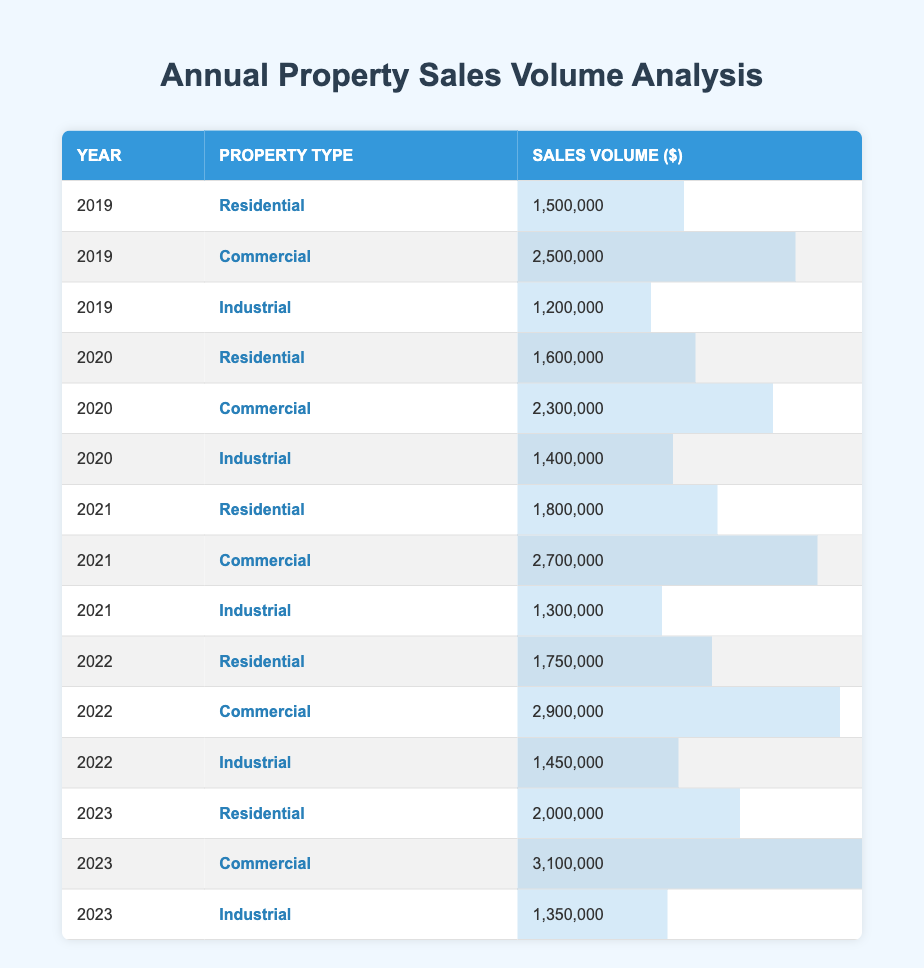What was the sales volume for Commercial properties in 2022? The table shows the row for 2022 under the Commercial property type, which states that the sales volume is 2,900,000.
Answer: 2,900,000 Which property type had the highest sales volume in 2021? In the table, the sales volumes for 2021 are 1,800,000 for Residential, 2,700,000 for Commercial, and 1,300,000 for Industrial. Among these, Commercial has the highest sales volume of 2,700,000.
Answer: Commercial What is the total sales volume for Residential properties over the last 5 years? To find the total sales volume for Residential properties, we sum the volumes for each year: 1,500,000 (2019) + 1,600,000 (2020) + 1,800,000 (2021) + 1,750,000 (2022) + 2,000,000 (2023) = 8,650,000.
Answer: 8,650,000 Was the sales volume for Industrial properties greater in 2020 than in 2019? In the table, the sales volume for Industrial properties in 2019 is 1,200,000 and for 2020 is 1,400,000. Since 1,400,000 is greater than 1,200,000, the answer is yes.
Answer: Yes What is the average sales volume for Commercial properties over the last 5 years? The sales volumes for Commercial properties over the last 5 years are 2,500,000 (2019), 2,300,000 (2020), 2,700,000 (2021), 2,900,000 (2022), and 3,100,000 (2023). Summing these gives 13,500,000. Dividing by 5 (the number of years) gives an average of 2,700,000.
Answer: 2,700,000 In which year did the Industrial property type see a decrease in sales volume compared to the previous year? By examining the table, we note the sales volumes for Industrial: 1,200,000 in 2019, 1,400,000 in 2020 (increase), 1,300,000 in 2021 (decrease from previous year), 1,450,000 in 2022 (increase), and 1,350,000 in 2023 (decrease from previous year). The decreases occurred in 2021 and 2023.
Answer: 2021 and 2023 What was the percentage increase in sales volume for Residential properties from 2020 to 2023? The sales volume for Residential properties in 2020 is 1,600,000 and in 2023 is 2,000,000. The increase is 2,000,000 - 1,600,000 = 400,000. To find the percentage increase, we calculate (400,000 / 1,600,000) * 100 = 25%.
Answer: 25% Did the average sales volume for Industrial properties exceed 1,500,000 over the 5 years? The total sales volume for Industrial properties is 1,200,000 (2019) + 1,400,000 (2020) + 1,300,000 (2021) + 1,450,000 (2022) + 1,350,000 (2023) = 6,700,000. Dividing by 5 gives an average of 1,340,000, which does not exceed 1,500,000.
Answer: No Which property type had the lowest sales volume over the 5-year period? By analyzing the total sales for each property type: Residential is 8,650,000, Commercial is 13,500,000, and Industrial is 6,700,000. Comparing these totals shows that Industrial has the lowest sales volume of 6,700,000.
Answer: Industrial 